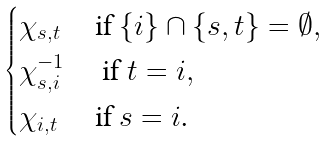<formula> <loc_0><loc_0><loc_500><loc_500>\begin{cases} \chi _ { s , t } & \text {if $\{i\} \cap \{s,t\} = \emptyset$} , \\ \chi _ { s , i } ^ { - 1 } & \text { if $t = i$} , \\ \chi _ { i , t } & \text {if $s = i$.} \end{cases}</formula> 